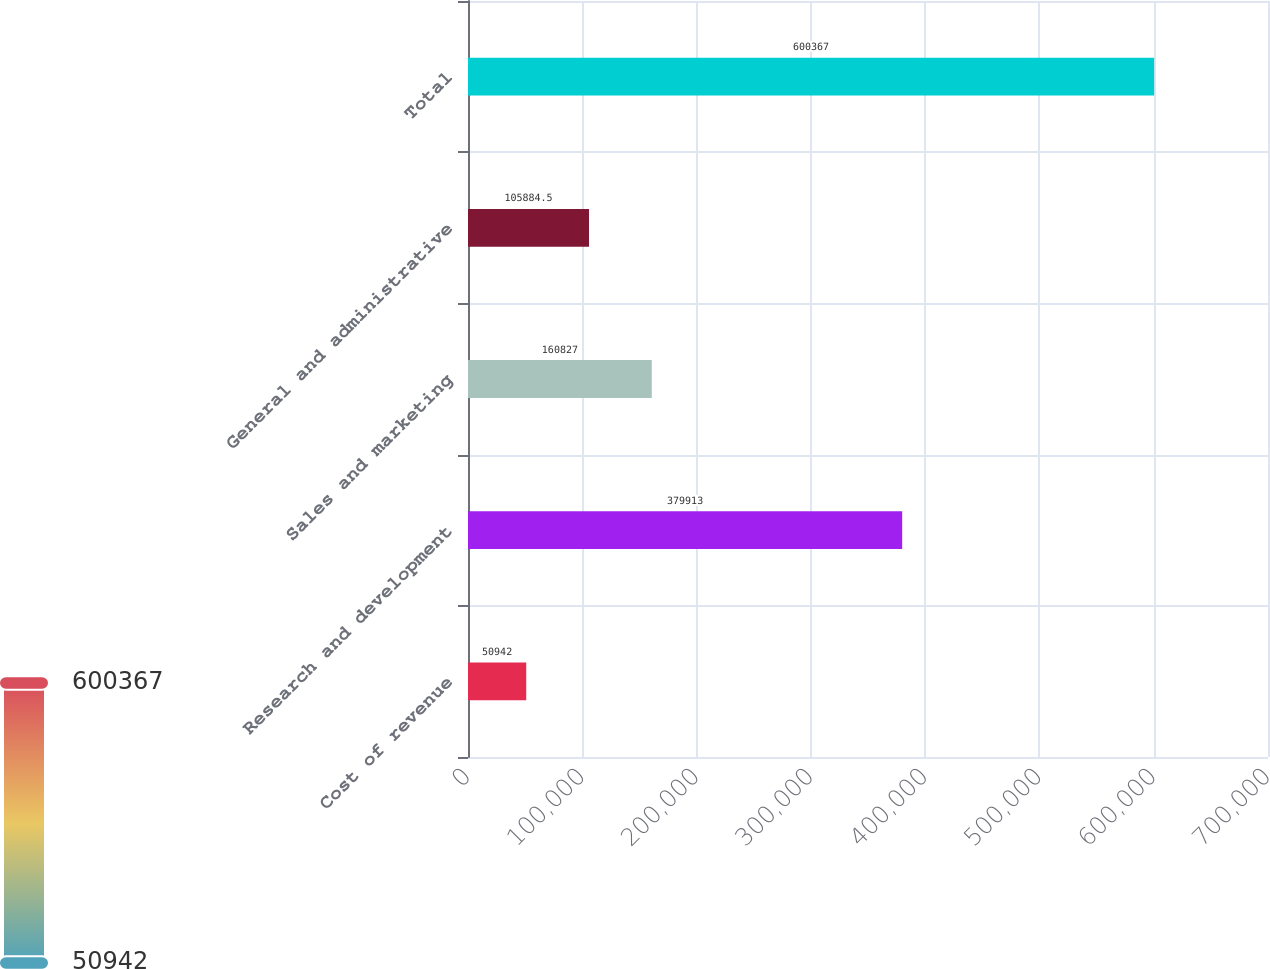Convert chart. <chart><loc_0><loc_0><loc_500><loc_500><bar_chart><fcel>Cost of revenue<fcel>Research and development<fcel>Sales and marketing<fcel>General and administrative<fcel>Total<nl><fcel>50942<fcel>379913<fcel>160827<fcel>105884<fcel>600367<nl></chart> 